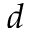Convert formula to latex. <formula><loc_0><loc_0><loc_500><loc_500>d</formula> 